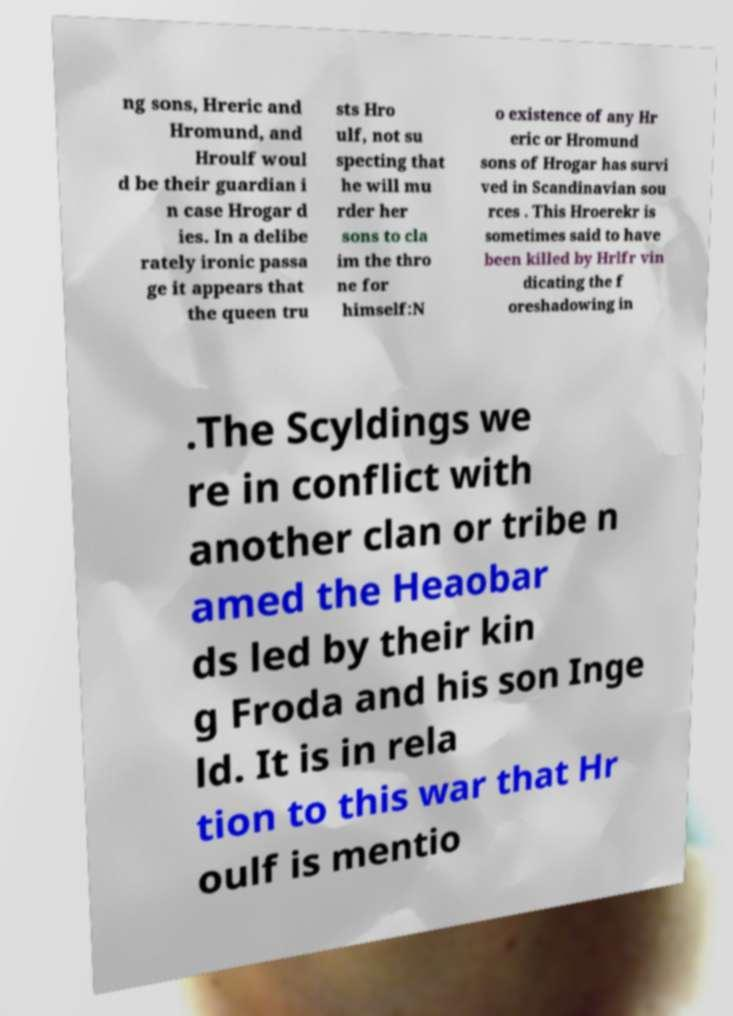What messages or text are displayed in this image? I need them in a readable, typed format. ng sons, Hreric and Hromund, and Hroulf woul d be their guardian i n case Hrogar d ies. In a delibe rately ironic passa ge it appears that the queen tru sts Hro ulf, not su specting that he will mu rder her sons to cla im the thro ne for himself:N o existence of any Hr eric or Hromund sons of Hrogar has survi ved in Scandinavian sou rces . This Hroerekr is sometimes said to have been killed by Hrlfr vin dicating the f oreshadowing in .The Scyldings we re in conflict with another clan or tribe n amed the Heaobar ds led by their kin g Froda and his son Inge ld. It is in rela tion to this war that Hr oulf is mentio 